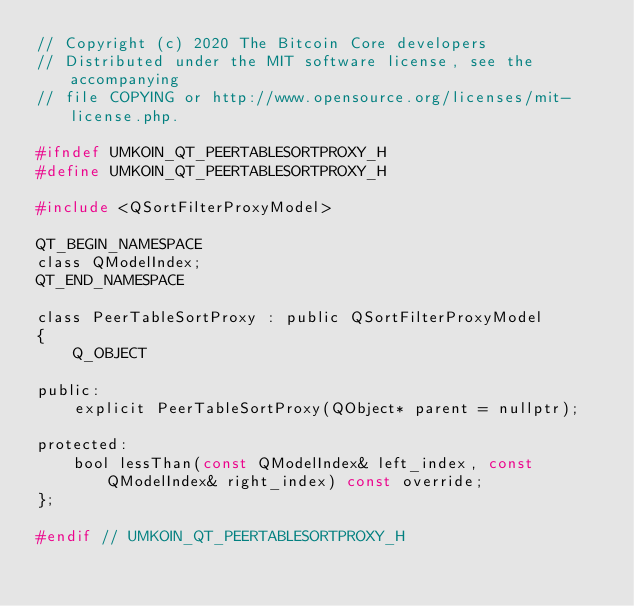<code> <loc_0><loc_0><loc_500><loc_500><_C_>// Copyright (c) 2020 The Bitcoin Core developers
// Distributed under the MIT software license, see the accompanying
// file COPYING or http://www.opensource.org/licenses/mit-license.php.

#ifndef UMKOIN_QT_PEERTABLESORTPROXY_H
#define UMKOIN_QT_PEERTABLESORTPROXY_H

#include <QSortFilterProxyModel>

QT_BEGIN_NAMESPACE
class QModelIndex;
QT_END_NAMESPACE

class PeerTableSortProxy : public QSortFilterProxyModel
{
    Q_OBJECT

public:
    explicit PeerTableSortProxy(QObject* parent = nullptr);

protected:
    bool lessThan(const QModelIndex& left_index, const QModelIndex& right_index) const override;
};

#endif // UMKOIN_QT_PEERTABLESORTPROXY_H
</code> 